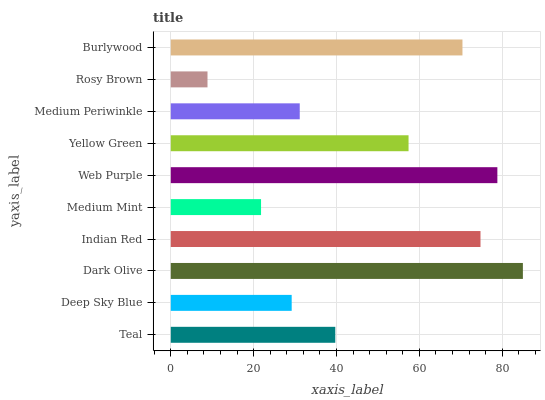Is Rosy Brown the minimum?
Answer yes or no. Yes. Is Dark Olive the maximum?
Answer yes or no. Yes. Is Deep Sky Blue the minimum?
Answer yes or no. No. Is Deep Sky Blue the maximum?
Answer yes or no. No. Is Teal greater than Deep Sky Blue?
Answer yes or no. Yes. Is Deep Sky Blue less than Teal?
Answer yes or no. Yes. Is Deep Sky Blue greater than Teal?
Answer yes or no. No. Is Teal less than Deep Sky Blue?
Answer yes or no. No. Is Yellow Green the high median?
Answer yes or no. Yes. Is Teal the low median?
Answer yes or no. Yes. Is Dark Olive the high median?
Answer yes or no. No. Is Indian Red the low median?
Answer yes or no. No. 